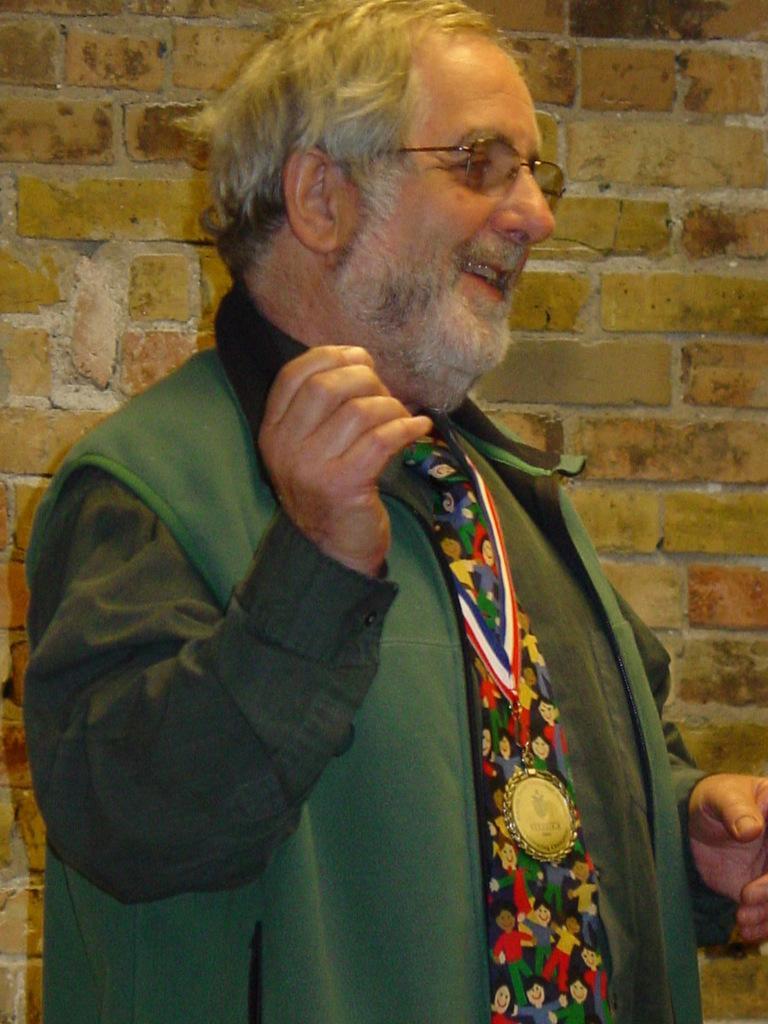How would you summarize this image in a sentence or two? In this image in the front there is a man standing and smiling. In the background there is a wall. 